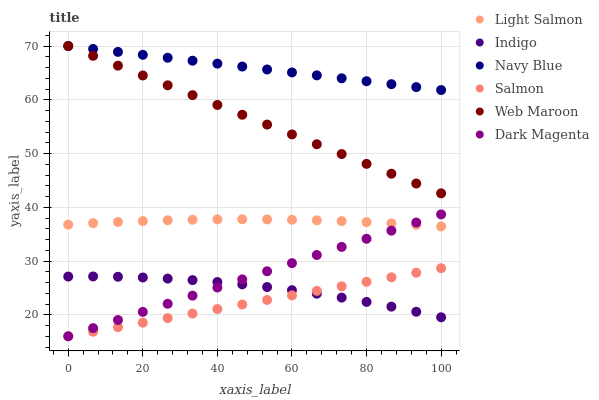Does Salmon have the minimum area under the curve?
Answer yes or no. Yes. Does Navy Blue have the maximum area under the curve?
Answer yes or no. Yes. Does Indigo have the minimum area under the curve?
Answer yes or no. No. Does Indigo have the maximum area under the curve?
Answer yes or no. No. Is Salmon the smoothest?
Answer yes or no. Yes. Is Indigo the roughest?
Answer yes or no. Yes. Is Dark Magenta the smoothest?
Answer yes or no. No. Is Dark Magenta the roughest?
Answer yes or no. No. Does Dark Magenta have the lowest value?
Answer yes or no. Yes. Does Indigo have the lowest value?
Answer yes or no. No. Does Web Maroon have the highest value?
Answer yes or no. Yes. Does Dark Magenta have the highest value?
Answer yes or no. No. Is Salmon less than Navy Blue?
Answer yes or no. Yes. Is Light Salmon greater than Indigo?
Answer yes or no. Yes. Does Salmon intersect Indigo?
Answer yes or no. Yes. Is Salmon less than Indigo?
Answer yes or no. No. Is Salmon greater than Indigo?
Answer yes or no. No. Does Salmon intersect Navy Blue?
Answer yes or no. No. 